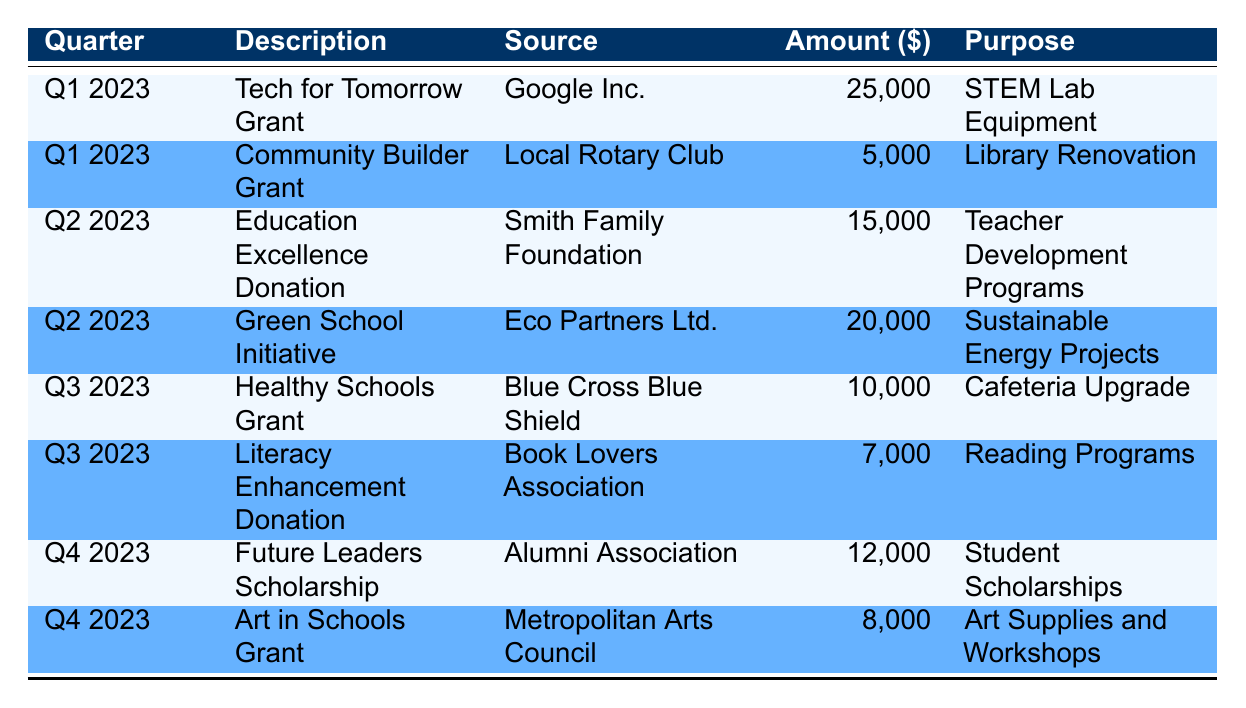What is the total amount of grants and donations received in Q1 2023? There are two entries for Q1 2023. The amounts are 25,000 and 5,000. Adding these gives 25,000 + 5,000 = 30,000.
Answer: 30,000 Which organization contributed the most in Q2 2023? In Q2 2023, there are two contributions: 15,000 from the Smith Family Foundation and 20,000 from Eco Partners Ltd. Since 20,000 is greater than 15,000, Eco Partners Ltd. is the organization that contributed the most.
Answer: Eco Partners Ltd Does the table indicate any donation specifically for literacy programs? There is a donation for literacy programs, specifically the "Literacy Enhancement Donation" from the Book Lovers Association for 7,000. Therefore, the answer is yes.
Answer: Yes What is the total amount of funding for student-related purposes (including scholarships and teacher development)? The relevant amounts are for "Future Leaders Scholarship" (12,000) and "Education Excellence Donation" (15,000). Therefore, the total is 12,000 + 15,000 = 27,000.
Answer: 27,000 Which quarter had the highest single grant amount, and what was the amount? By comparing the amounts across all quarters: Q1 had 25,000 and 5,000, Q2 had 15,000 and 20,000, Q3 had 10,000 and 7,000, Q4 had 12,000 and 8,000. The highest single grant is 25,000 in Q1.
Answer: Q1, 25,000 What is the average amount of donations received in Q3 2023? In Q3 2023, there are two donations of 10,000 and 7,000. To find the average, sum these amounts: 10,000 + 7,000 = 17,000. Then divide by the number of donations (2): 17,000 / 2 = 8,500.
Answer: 8,500 Is there any grant aimed at cafeteria improvements? Yes, the "Healthy Schools Grant" from Blue Cross Blue Shield is specifically aimed at the cafeteria upgrade, which is mentioned as its purpose.
Answer: Yes What is the total amount received across all quarters for sustainability-related projects? The "Green School Initiative" for Q2 contributes 20,000 for sustainability projects. There are no other sustainability-related grants in the table. Thus, the total is 20,000.
Answer: 20,000 Which purpose received the least funding, and how much was it? The "Literacy Enhancement Donation" for reading programs received 7,000, which is the least amount compared to other purposes.
Answer: Reading Programs, 7,000 